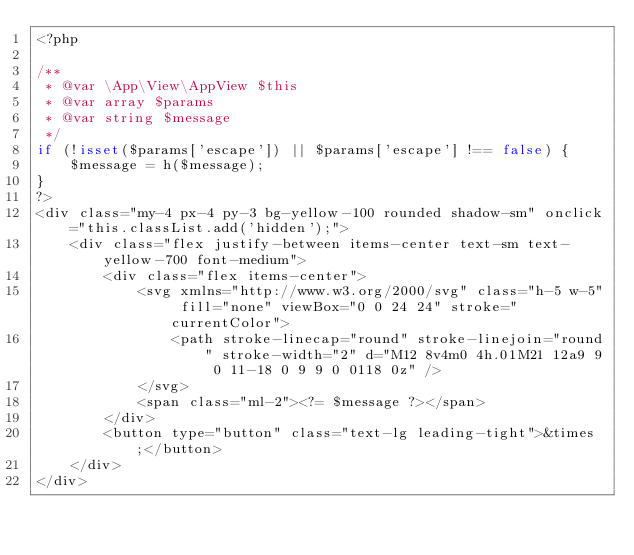Convert code to text. <code><loc_0><loc_0><loc_500><loc_500><_PHP_><?php

/**
 * @var \App\View\AppView $this
 * @var array $params
 * @var string $message
 */
if (!isset($params['escape']) || $params['escape'] !== false) {
    $message = h($message);
}
?>
<div class="my-4 px-4 py-3 bg-yellow-100 rounded shadow-sm" onclick="this.classList.add('hidden');">
    <div class="flex justify-between items-center text-sm text-yellow-700 font-medium">
        <div class="flex items-center">
            <svg xmlns="http://www.w3.org/2000/svg" class="h-5 w-5" fill="none" viewBox="0 0 24 24" stroke="currentColor">
                <path stroke-linecap="round" stroke-linejoin="round" stroke-width="2" d="M12 8v4m0 4h.01M21 12a9 9 0 11-18 0 9 9 0 0118 0z" />
            </svg>
            <span class="ml-2"><?= $message ?></span>
        </div>
        <button type="button" class="text-lg leading-tight">&times;</button>
    </div>
</div></code> 